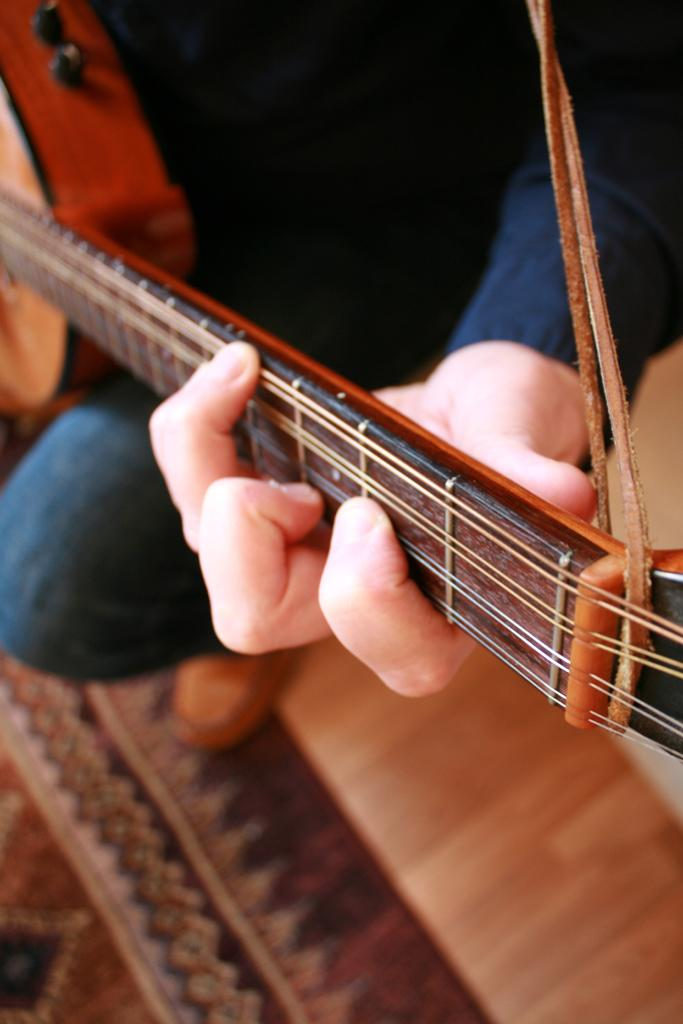What is the main subject of the image? There is a person in the image. What is the person wearing? The person is wearing clothes. What activity is the person engaged in? The person is playing a guitar. How many children are playing with the stamp in the image? There is no stamp or children present in the image. 